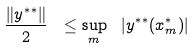<formula> <loc_0><loc_0><loc_500><loc_500>\frac { \| y ^ { * * } \| } { 2 } \ \leq \sup _ { m } \ | y ^ { * * } ( x ^ { * } _ { m } ) |</formula> 